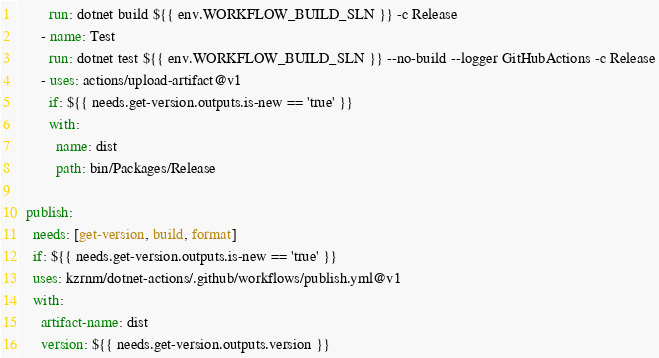<code> <loc_0><loc_0><loc_500><loc_500><_YAML_>        run: dotnet build ${{ env.WORKFLOW_BUILD_SLN }} -c Release
      - name: Test
        run: dotnet test ${{ env.WORKFLOW_BUILD_SLN }} --no-build --logger GitHubActions -c Release
      - uses: actions/upload-artifact@v1
        if: ${{ needs.get-version.outputs.is-new == 'true' }}
        with:
          name: dist
          path: bin/Packages/Release

  publish:
    needs: [get-version, build, format]
    if: ${{ needs.get-version.outputs.is-new == 'true' }}
    uses: kzrnm/dotnet-actions/.github/workflows/publish.yml@v1
    with:
      artifact-name: dist
      version: ${{ needs.get-version.outputs.version }}</code> 